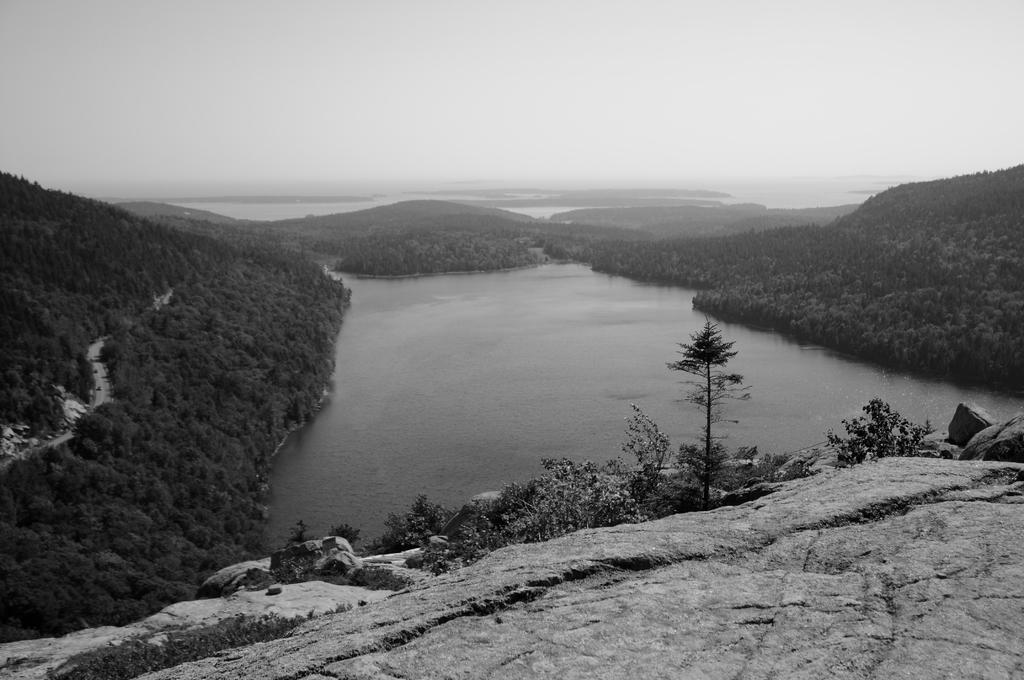In one or two sentences, can you explain what this image depicts? This is a black and white image. In this image we can see some plants on the hill. On the backside we can see a large water body, a group of trees on the hill, a pathway and the sky which looks cloudy. 